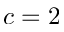Convert formula to latex. <formula><loc_0><loc_0><loc_500><loc_500>c = 2</formula> 